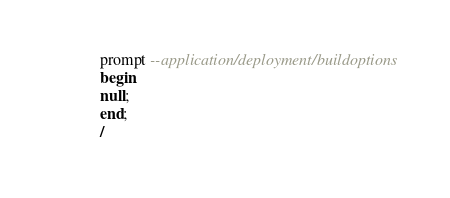<code> <loc_0><loc_0><loc_500><loc_500><_SQL_>prompt --application/deployment/buildoptionsbeginnull;end;/</code> 